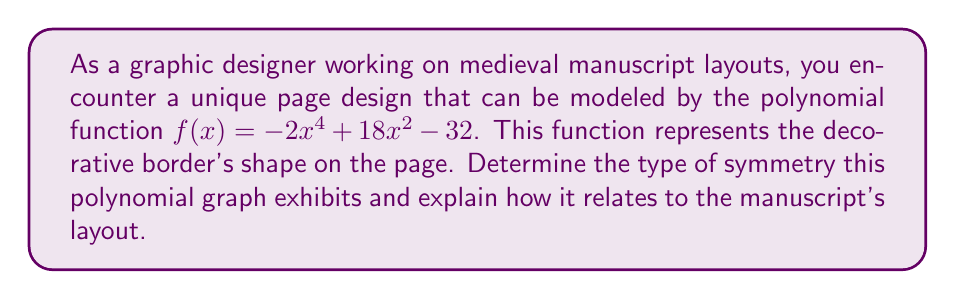Show me your answer to this math problem. To determine the symmetry of the polynomial graph, we need to analyze its properties:

1. Degree of the polynomial:
   The polynomial $f(x) = -2x^4 + 18x^2 - 32$ is of degree 4 (even).

2. Presence of odd-degree terms:
   There are no odd-degree terms (x^1 or x^3) in this polynomial.

3. General form:
   The polynomial can be written as $f(x) = a(x^2)^2 + b(x^2) + c$, where:
   $a = -2$
   $b = 18$
   $c = -32$

These properties indicate that the graph is symmetric about the y-axis.

To verify this symmetry:

1. Test for even function: $f(-x) = f(x)$
   $f(-x) = -2(-x)^4 + 18(-x)^2 - 32$
          $= -2x^4 + 18x^2 - 32$
          $= f(x)$

2. Y-intercept:
   When $x = 0$, $f(0) = -32$

3. Axis of symmetry:
   The axis of symmetry is the y-axis, represented by the equation $x = 0$.

In the context of medieval manuscript layout:
- The y-axis symmetry implies that the decorative border is perfectly mirrored on both sides of the central vertical line of the page.
- This symmetrical design was common in medieval manuscripts, emphasizing balance and harmony in the page layout.
- The y-intercept at -32 might represent the bottom margin of the page, while the curve's shape could outline the text area or illustrate the curvature of decorative elements.
Answer: The polynomial graph exhibits y-axis symmetry (even function symmetry), which in the context of the medieval manuscript layout, represents a perfectly balanced decorative border design mirrored on both sides of the page's central vertical line. 